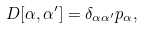<formula> <loc_0><loc_0><loc_500><loc_500>D [ \alpha , \alpha ^ { \prime } ] = \delta _ { \alpha \alpha ^ { \prime } } p _ { \alpha } ,</formula> 